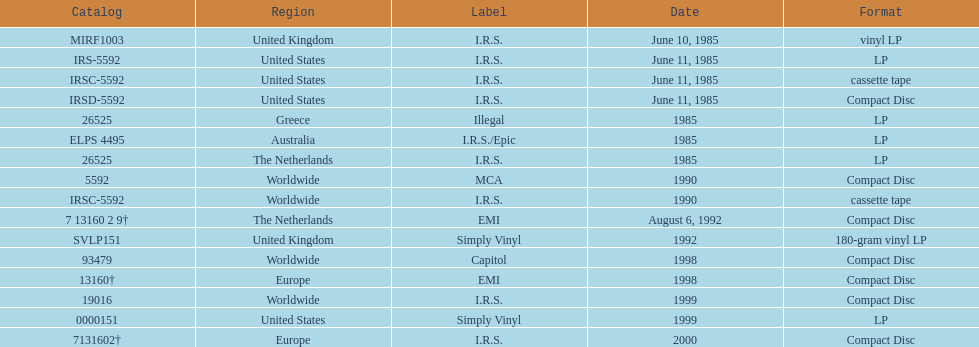Name another region for the 1985 release other than greece. Australia. Parse the table in full. {'header': ['Catalog', 'Region', 'Label', 'Date', 'Format'], 'rows': [['MIRF1003', 'United Kingdom', 'I.R.S.', 'June 10, 1985', 'vinyl LP'], ['IRS-5592', 'United States', 'I.R.S.', 'June 11, 1985', 'LP'], ['IRSC-5592', 'United States', 'I.R.S.', 'June 11, 1985', 'cassette tape'], ['IRSD-5592', 'United States', 'I.R.S.', 'June 11, 1985', 'Compact Disc'], ['26525', 'Greece', 'Illegal', '1985', 'LP'], ['ELPS 4495', 'Australia', 'I.R.S./Epic', '1985', 'LP'], ['26525', 'The Netherlands', 'I.R.S.', '1985', 'LP'], ['5592', 'Worldwide', 'MCA', '1990', 'Compact Disc'], ['IRSC-5592', 'Worldwide', 'I.R.S.', '1990', 'cassette tape'], ['7 13160 2 9†', 'The Netherlands', 'EMI', 'August 6, 1992', 'Compact Disc'], ['SVLP151', 'United Kingdom', 'Simply Vinyl', '1992', '180-gram vinyl LP'], ['93479', 'Worldwide', 'Capitol', '1998', 'Compact Disc'], ['13160†', 'Europe', 'EMI', '1998', 'Compact Disc'], ['19016', 'Worldwide', 'I.R.S.', '1999', 'Compact Disc'], ['0000151', 'United States', 'Simply Vinyl', '1999', 'LP'], ['7131602†', 'Europe', 'I.R.S.', '2000', 'Compact Disc']]} 